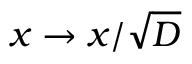Convert formula to latex. <formula><loc_0><loc_0><loc_500><loc_500>x \to x / \sqrt { D }</formula> 